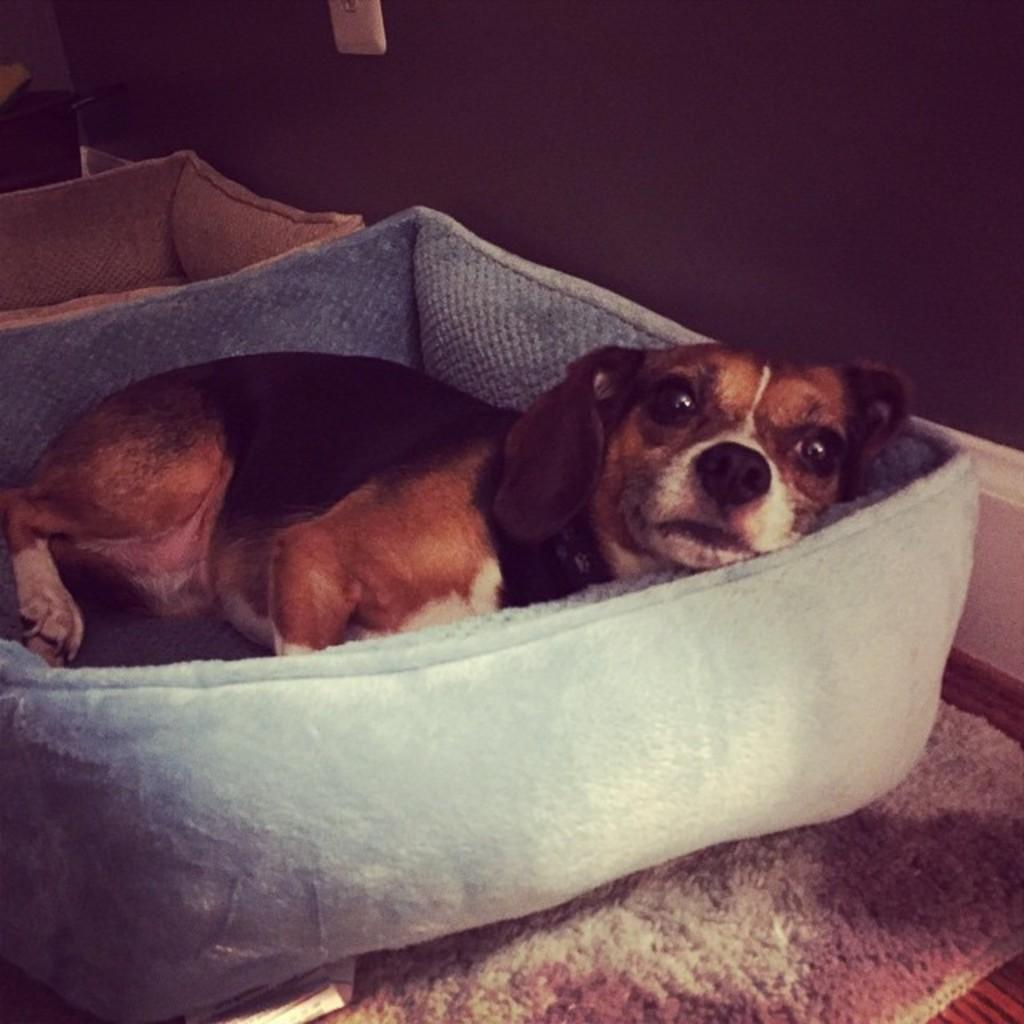What type of animal is in the image? There is a dog in the image. Where is the dog located? The dog is in a pet bed. Are there any other pet beds in the image? Yes, there is another pet bed in the image. What type of flooring is visible in the image? There is a carpet in the image. What can be seen in the background of the image? There is a wall in the background of the image. What type of book is the dog reading in the image? There is no book present in the image, and the dog is not shown reading anything. 